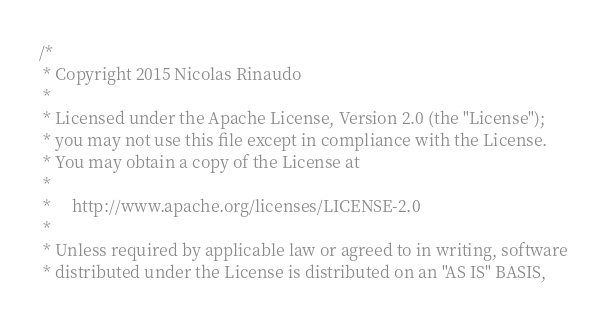Convert code to text. <code><loc_0><loc_0><loc_500><loc_500><_Scala_>/*
 * Copyright 2015 Nicolas Rinaudo
 *
 * Licensed under the Apache License, Version 2.0 (the "License");
 * you may not use this file except in compliance with the License.
 * You may obtain a copy of the License at
 *
 *     http://www.apache.org/licenses/LICENSE-2.0
 *
 * Unless required by applicable law or agreed to in writing, software
 * distributed under the License is distributed on an "AS IS" BASIS,</code> 